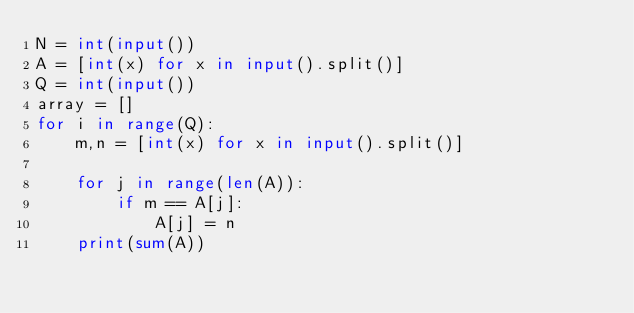<code> <loc_0><loc_0><loc_500><loc_500><_Python_>N = int(input())
A = [int(x) for x in input().split()]
Q = int(input())
array = []
for i in range(Q):
    m,n = [int(x) for x in input().split()]

    for j in range(len(A)):
        if m == A[j]:
            A[j] = n
    print(sum(A))</code> 